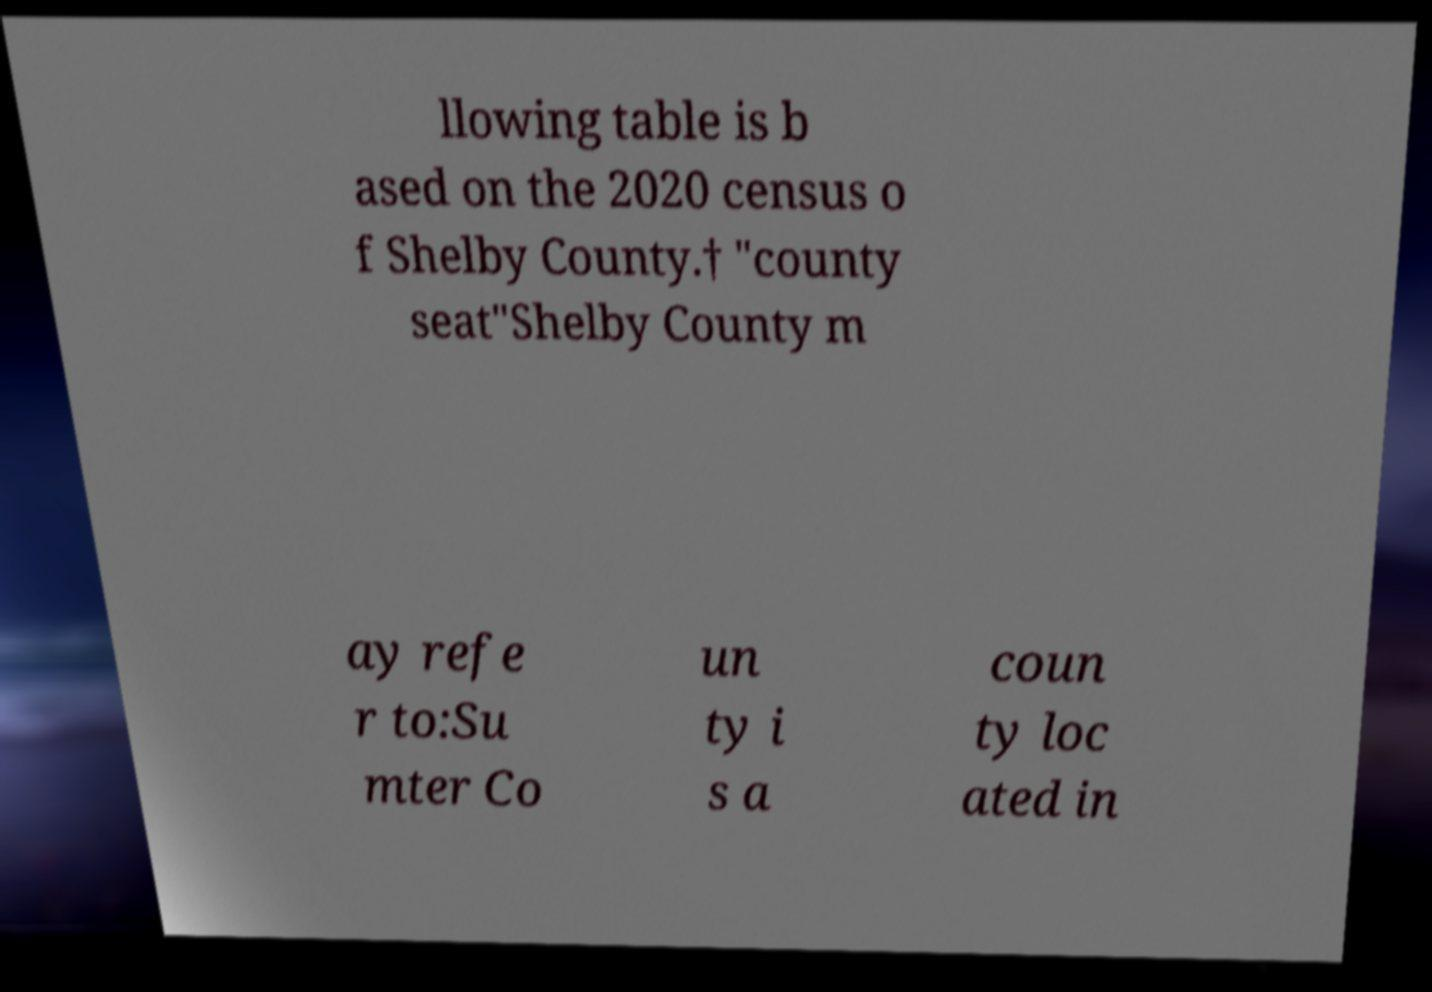Please identify and transcribe the text found in this image. llowing table is b ased on the 2020 census o f Shelby County.† "county seat"Shelby County m ay refe r to:Su mter Co un ty i s a coun ty loc ated in 